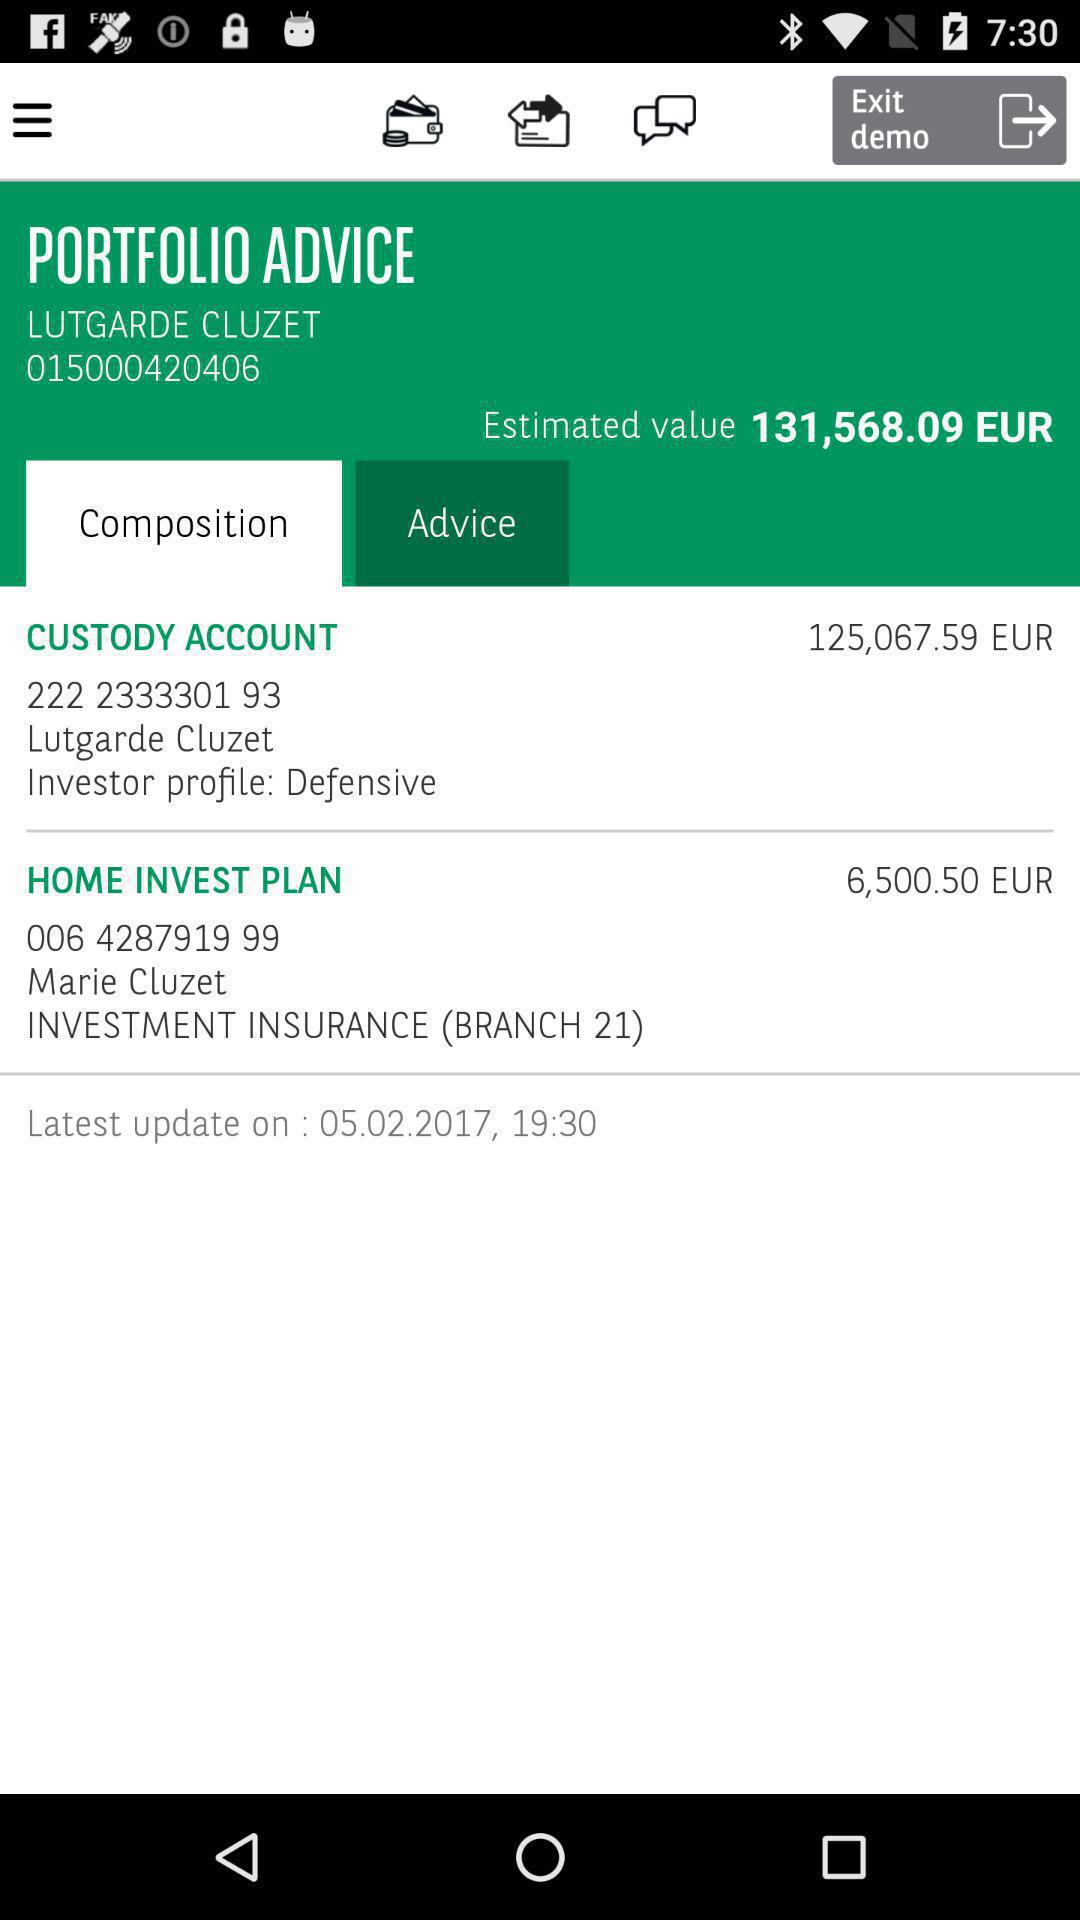What is the total value of all the items in the portfolio?
Answer the question using a single word or phrase. 131,568.09 EUR 